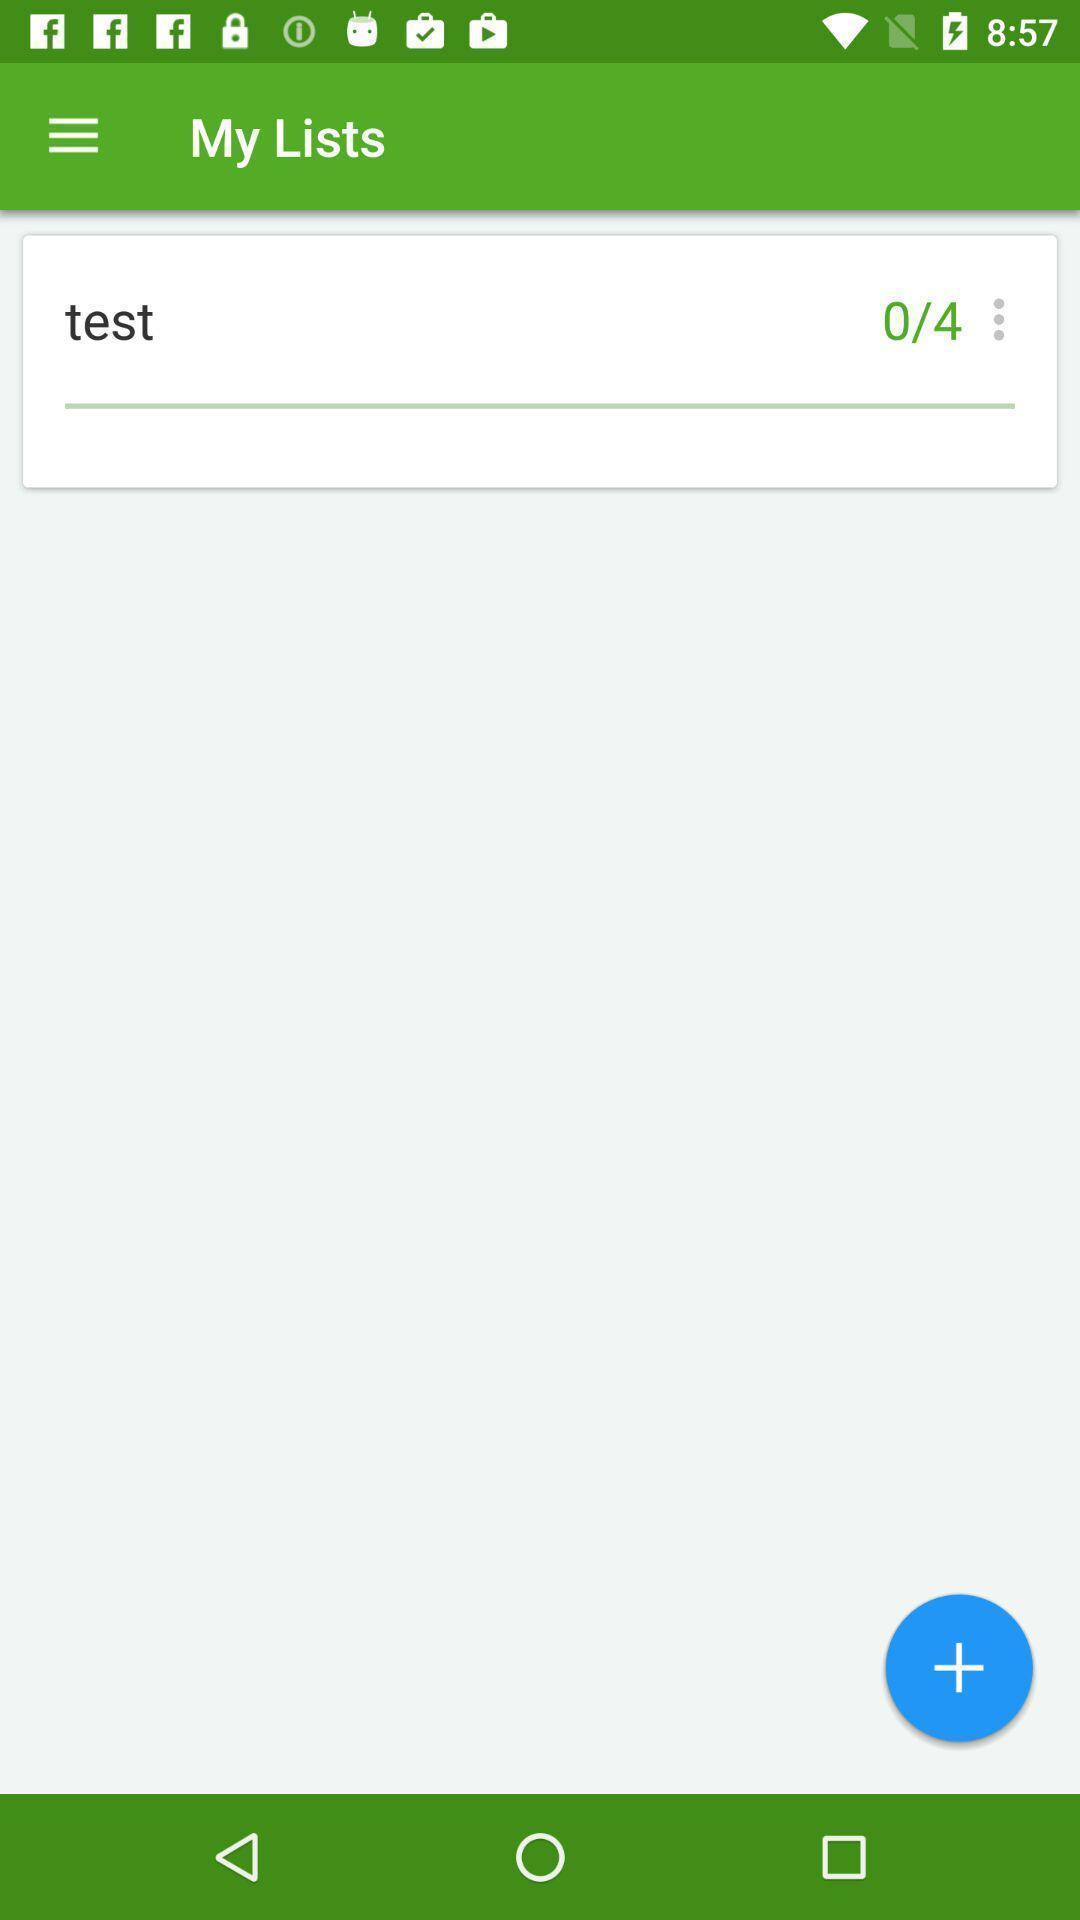Summarize the main components in this picture. Test of a my list app. 